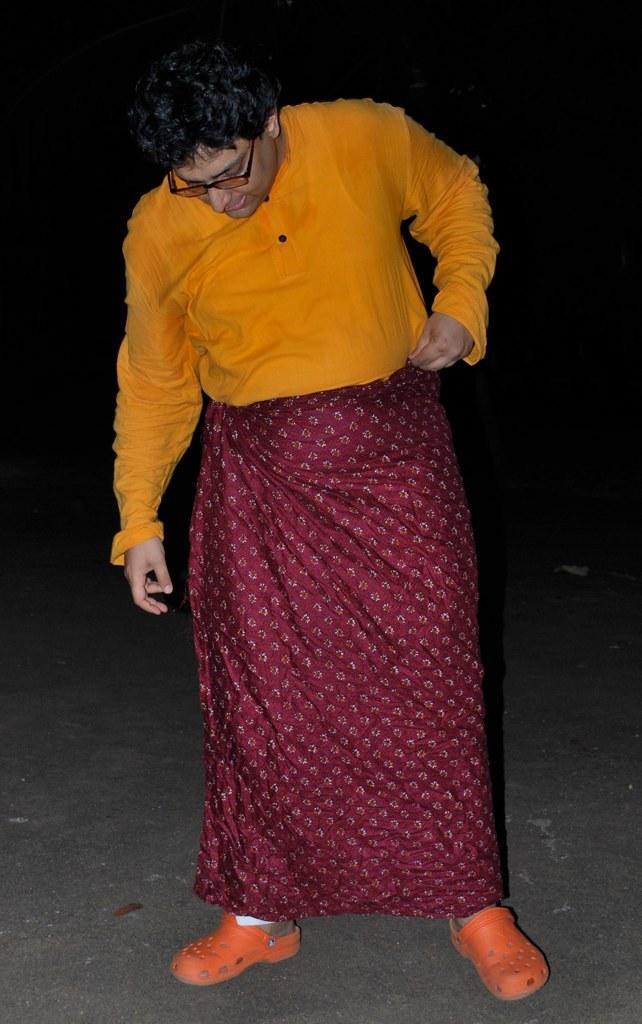Can you describe this image briefly? In the foreground I can see a person is standing on the road. The background is dark in color. This image is taken may be during night. 